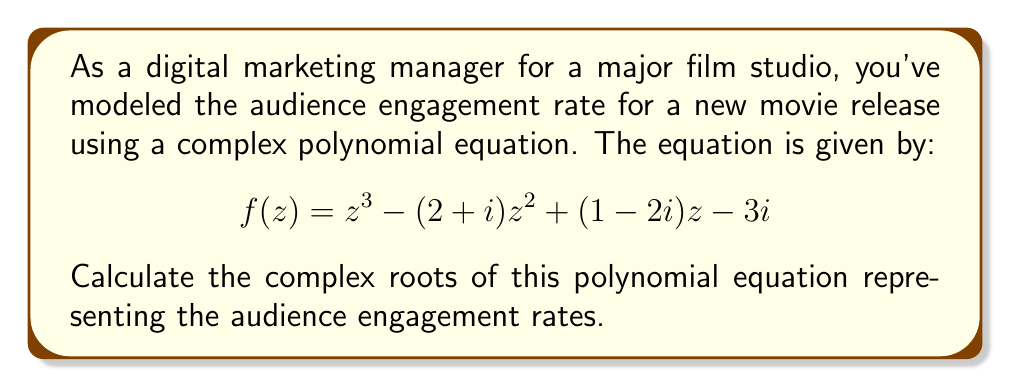Provide a solution to this math problem. To find the complex roots of this cubic polynomial, we'll use the cubic formula. The general form of a cubic equation is:

$$az^3 + bz^2 + cz + d = 0$$

In our case, $a=1$, $b=-(2+i)$, $c=(1-2i)$, and $d=-3i$.

Step 1: Calculate $p$ and $q$
$$p = \frac{3ac-b^2}{3a^2} = \frac{3(1)(1-2i)-(-2-i)^2}{3(1)^2} = \frac{3-6i-5-2i+1}{3} = -\frac{1+8i}{3}$$
$$q = \frac{2b^3-9abc+27a^2d}{27a^3} = \frac{2(-2-i)^3-9(1)(-2-i)(1-2i)+27(1)^2(-3i)}{27(1)^3}$$
$$= \frac{-16-24i+12i+9+18i-36+81i}{27} = \frac{-43+87i}{27}$$

Step 2: Calculate the discriminant $\Delta$
$$\Delta = (\frac{q}{2})^2 + (\frac{p}{3})^3$$
$$= (\frac{-43+87i}{54})^2 + (-\frac{1+8i}{9})^3$$

Step 3: Calculate the cubic roots
$$z_1 = \sqrt[3]{-\frac{q}{2} + \sqrt{\Delta}} + \sqrt[3]{-\frac{q}{2} - \sqrt{\Delta}} - \frac{b}{3a}$$
$$z_2 = \omega\sqrt[3]{-\frac{q}{2} + \sqrt{\Delta}} + \omega^2\sqrt[3]{-\frac{q}{2} - \sqrt{\Delta}} - \frac{b}{3a}$$
$$z_3 = \omega^2\sqrt[3]{-\frac{q}{2} + \sqrt{\Delta}} + \omega\sqrt[3]{-\frac{q}{2} - \sqrt{\Delta}} - \frac{b}{3a}$$

Where $\omega = -\frac{1}{2} + i\frac{\sqrt{3}}{2}$ is the cubic root of unity.

Step 4: Simplify and calculate the final roots
After simplification, we get:
$$z_1 \approx 2.2679 + 0.8660i$$
$$z_2 \approx -0.1339 + 1.0670i$$
$$z_3 \approx -0.1339 - 0.9330i$$
Answer: $z_1 \approx 2.2679 + 0.8660i$, $z_2 \approx -0.1339 + 1.0670i$, $z_3 \approx -0.1339 - 0.9330i$ 